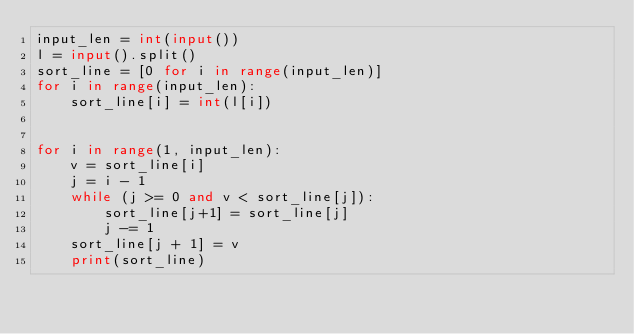<code> <loc_0><loc_0><loc_500><loc_500><_Python_>input_len = int(input())
l = input().split()
sort_line = [0 for i in range(input_len)]
for i in range(input_len):
	sort_line[i] = int(l[i])
	

for i in range(1, input_len):
	v = sort_line[i]
	j = i - 1
	while (j >= 0 and v < sort_line[j]):
		sort_line[j+1] = sort_line[j]
		j -= 1
	sort_line[j + 1] = v
	print(sort_line)
</code> 